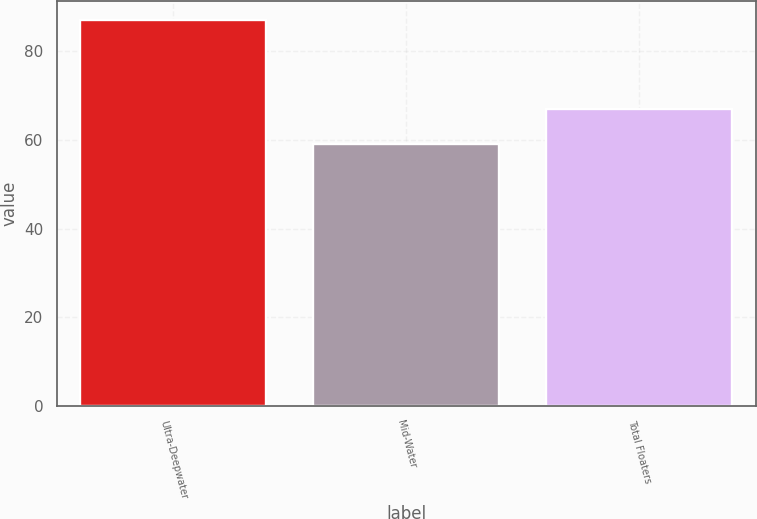<chart> <loc_0><loc_0><loc_500><loc_500><bar_chart><fcel>Ultra-Deepwater<fcel>Mid-Water<fcel>Total Floaters<nl><fcel>87<fcel>59<fcel>67<nl></chart> 